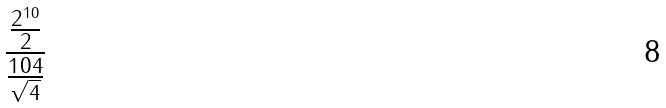<formula> <loc_0><loc_0><loc_500><loc_500>\frac { \frac { 2 ^ { 1 0 } } { 2 } } { \frac { 1 0 4 } { \sqrt { 4 } } }</formula> 